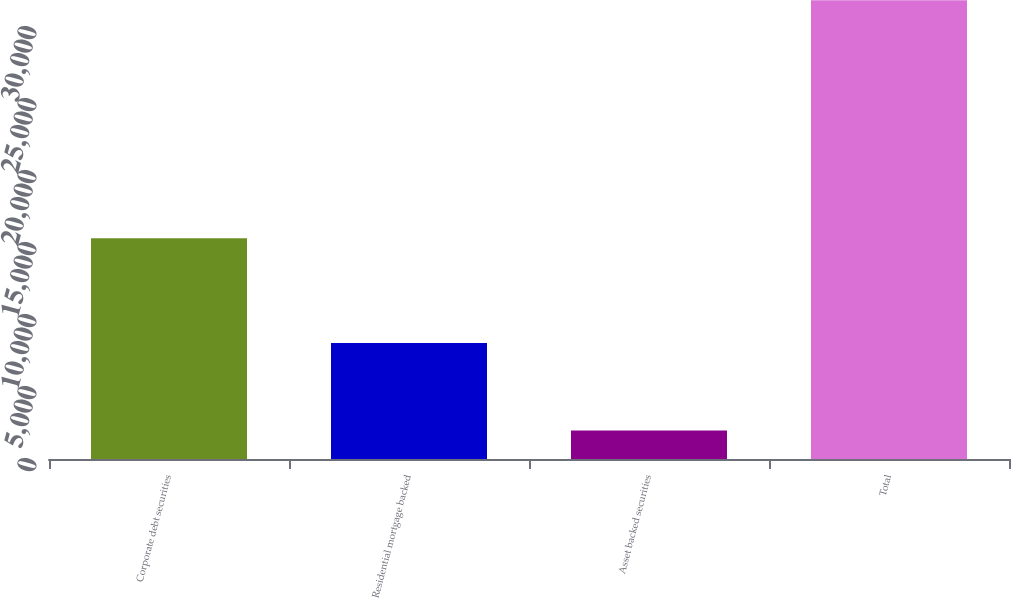Convert chart to OTSL. <chart><loc_0><loc_0><loc_500><loc_500><bar_chart><fcel>Corporate debt securities<fcel>Residential mortgage backed<fcel>Asset backed securities<fcel>Total<nl><fcel>15336<fcel>8050<fcel>1984<fcel>31860<nl></chart> 